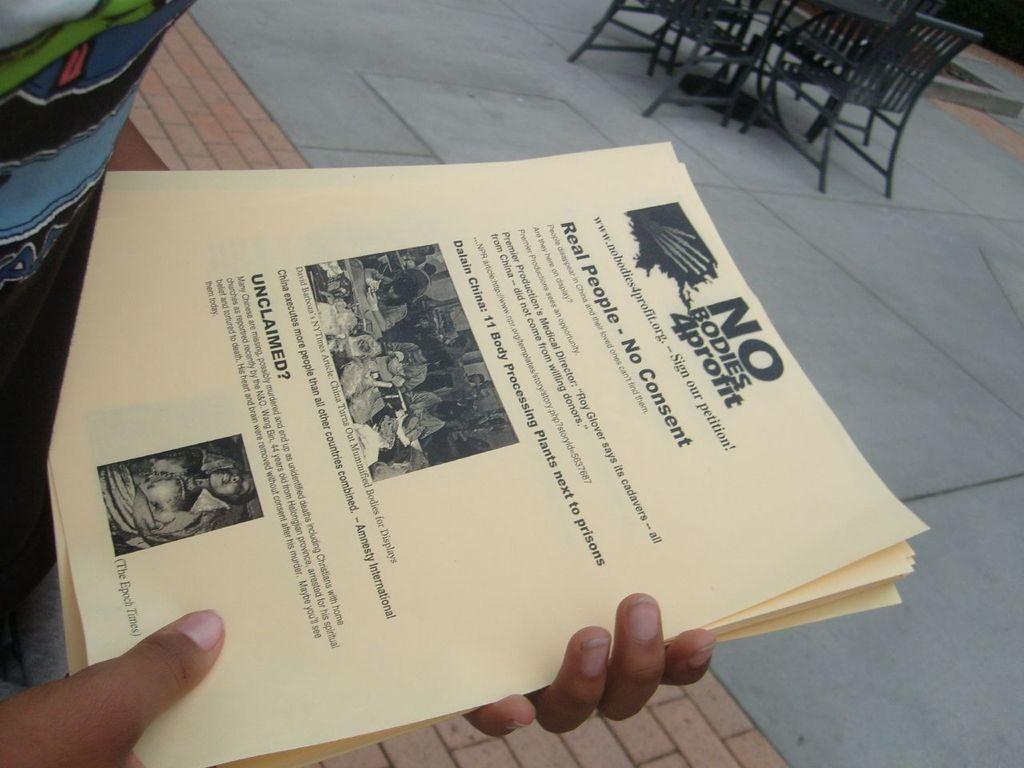What is the name of the company?
Offer a terse response. No bodies 4 profit. What kind of people does the poster claim?
Give a very brief answer. Real people. 